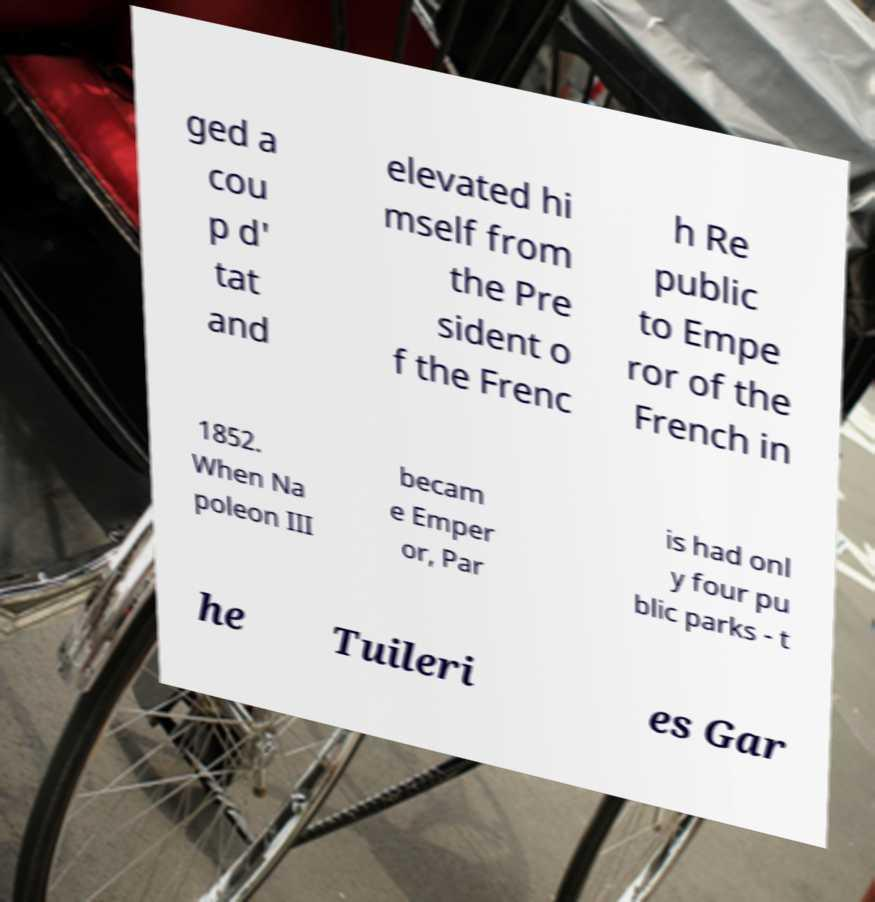What messages or text are displayed in this image? I need them in a readable, typed format. ged a cou p d' tat and elevated hi mself from the Pre sident o f the Frenc h Re public to Empe ror of the French in 1852. When Na poleon III becam e Emper or, Par is had onl y four pu blic parks - t he Tuileri es Gar 